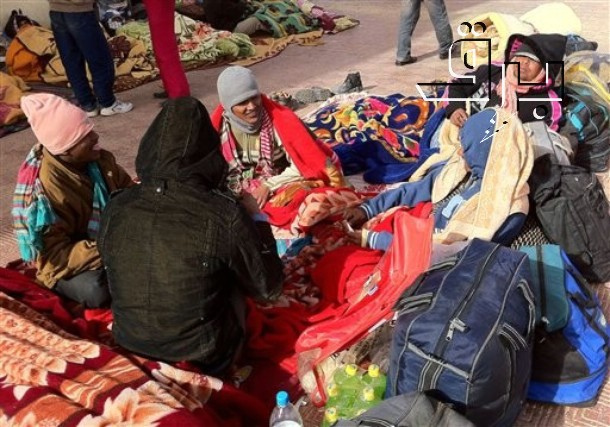How does this image make you feel, and why? This image evokes a sense of warmth and solidarity. Despite the cold environment suggested by their heavy winter clothing, the individuals appear to be finding comfort and companionship in each other's presence. The colorful blankets and bags add a touch of vibrancy, indicating that they strive to maintain some level of cheerfulness and normalcy. Seeing such a strong bond amidst challenging conditions brings a feeling of hope and resilience. 